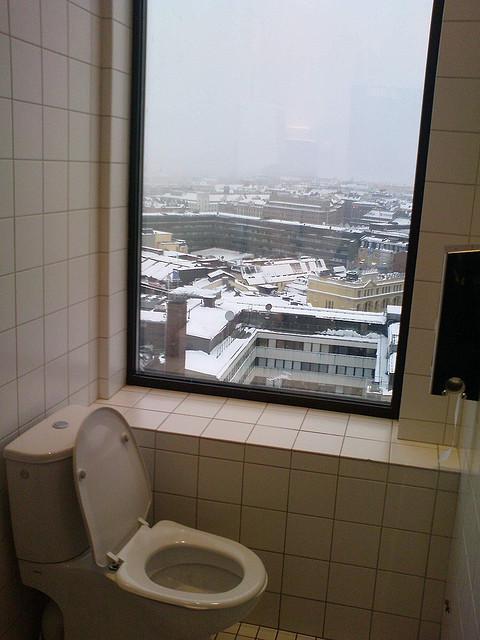What color is the tile?
Short answer required. White. What do you see outside the window?
Write a very short answer. City. What is the color of the toilet seat?
Quick response, please. White. 